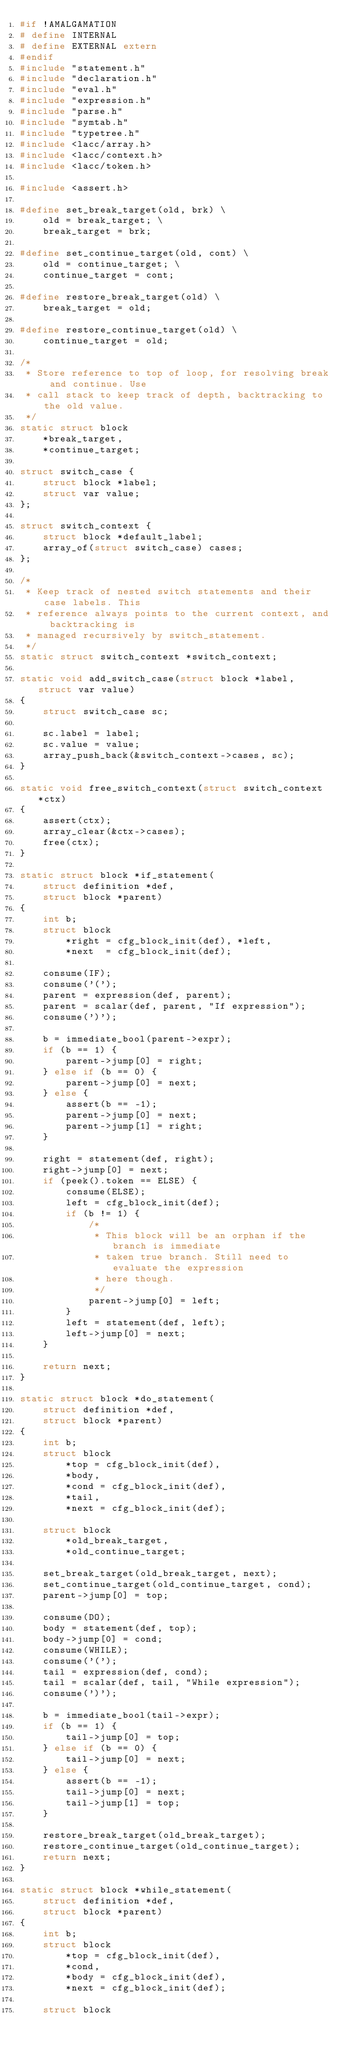<code> <loc_0><loc_0><loc_500><loc_500><_C_>#if !AMALGAMATION
# define INTERNAL
# define EXTERNAL extern
#endif
#include "statement.h"
#include "declaration.h"
#include "eval.h"
#include "expression.h"
#include "parse.h"
#include "symtab.h"
#include "typetree.h"
#include <lacc/array.h>
#include <lacc/context.h>
#include <lacc/token.h>

#include <assert.h>

#define set_break_target(old, brk) \
    old = break_target; \
    break_target = brk;

#define set_continue_target(old, cont) \
    old = continue_target; \
    continue_target = cont;

#define restore_break_target(old) \
    break_target = old;

#define restore_continue_target(old) \
    continue_target = old;

/*
 * Store reference to top of loop, for resolving break and continue. Use
 * call stack to keep track of depth, backtracking to the old value.
 */
static struct block
    *break_target,
    *continue_target;

struct switch_case {
    struct block *label;
    struct var value;
};

struct switch_context {
    struct block *default_label;
    array_of(struct switch_case) cases;
};

/*
 * Keep track of nested switch statements and their case labels. This
 * reference always points to the current context, and backtracking is
 * managed recursively by switch_statement.
 */
static struct switch_context *switch_context;

static void add_switch_case(struct block *label, struct var value)
{
    struct switch_case sc;

    sc.label = label;
    sc.value = value;
    array_push_back(&switch_context->cases, sc);
}

static void free_switch_context(struct switch_context *ctx)
{
    assert(ctx);
    array_clear(&ctx->cases);
    free(ctx);
}

static struct block *if_statement(
    struct definition *def,
    struct block *parent)
{
    int b;
    struct block
        *right = cfg_block_init(def), *left,
        *next  = cfg_block_init(def);

    consume(IF);
    consume('(');
    parent = expression(def, parent);
    parent = scalar(def, parent, "If expression");
    consume(')');

    b = immediate_bool(parent->expr);
    if (b == 1) {
        parent->jump[0] = right;
    } else if (b == 0) {
        parent->jump[0] = next;
    } else {
        assert(b == -1);
        parent->jump[0] = next;
        parent->jump[1] = right;
    }

    right = statement(def, right);
    right->jump[0] = next;
    if (peek().token == ELSE) {
        consume(ELSE);
        left = cfg_block_init(def);
        if (b != 1) {
            /*
             * This block will be an orphan if the branch is immediate
             * taken true branch. Still need to evaluate the expression
             * here though.
             */
            parent->jump[0] = left;
        }
        left = statement(def, left);
        left->jump[0] = next;
    }

    return next;
}

static struct block *do_statement(
    struct definition *def,
    struct block *parent)
{
    int b;
    struct block
        *top = cfg_block_init(def),
        *body,
        *cond = cfg_block_init(def),
        *tail,
        *next = cfg_block_init(def);

    struct block
        *old_break_target,
        *old_continue_target;

    set_break_target(old_break_target, next);
    set_continue_target(old_continue_target, cond);
    parent->jump[0] = top;

    consume(DO);
    body = statement(def, top);
    body->jump[0] = cond;
    consume(WHILE);
    consume('(');
    tail = expression(def, cond);
    tail = scalar(def, tail, "While expression");
    consume(')');

    b = immediate_bool(tail->expr);
    if (b == 1) {
        tail->jump[0] = top;
    } else if (b == 0) {
        tail->jump[0] = next;
    } else {
        assert(b == -1);
        tail->jump[0] = next;
        tail->jump[1] = top;
    }

    restore_break_target(old_break_target);
    restore_continue_target(old_continue_target);
    return next;
}

static struct block *while_statement(
    struct definition *def,
    struct block *parent)
{
    int b;
    struct block
        *top = cfg_block_init(def),
        *cond,
        *body = cfg_block_init(def),
        *next = cfg_block_init(def);

    struct block</code> 